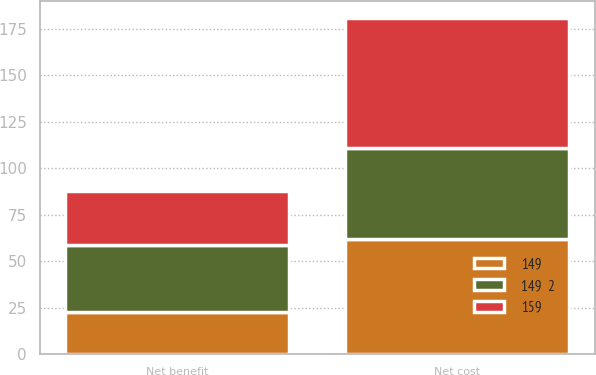Convert chart to OTSL. <chart><loc_0><loc_0><loc_500><loc_500><stacked_bar_chart><ecel><fcel>Net benefit<fcel>Net cost<nl><fcel>159<fcel>29<fcel>70<nl><fcel>149<fcel>23<fcel>62<nl><fcel>149  2<fcel>36<fcel>49<nl></chart> 